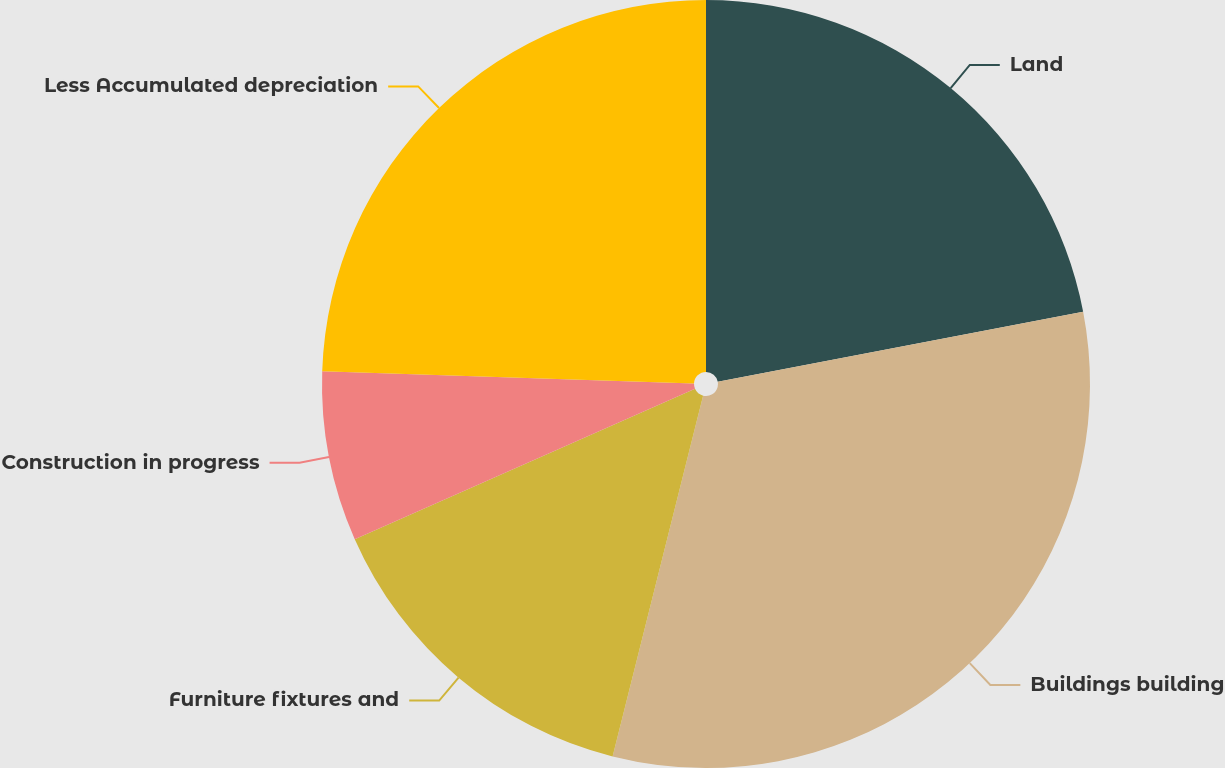<chart> <loc_0><loc_0><loc_500><loc_500><pie_chart><fcel>Land<fcel>Buildings building<fcel>Furniture fixtures and<fcel>Construction in progress<fcel>Less Accumulated depreciation<nl><fcel>21.99%<fcel>31.92%<fcel>14.47%<fcel>7.15%<fcel>24.47%<nl></chart> 